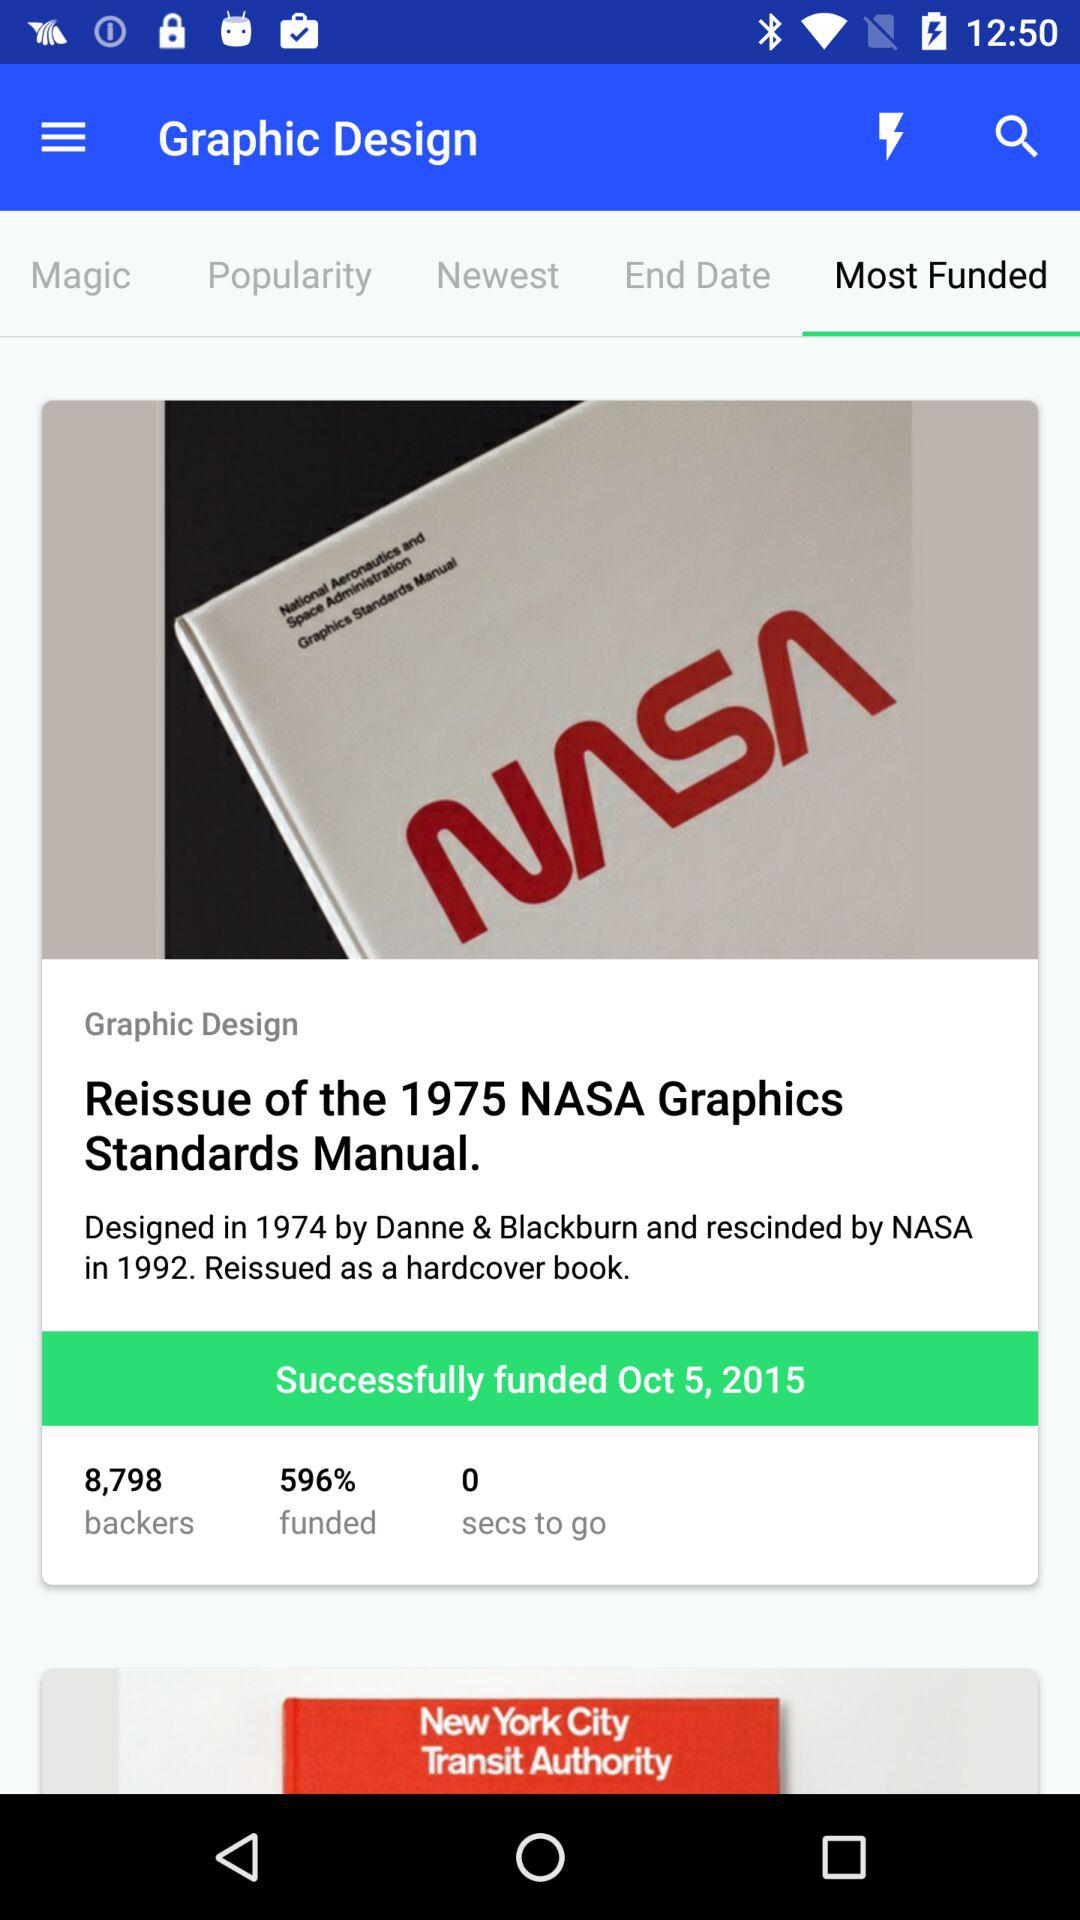How many backers are there? There are 8,798 backers. 